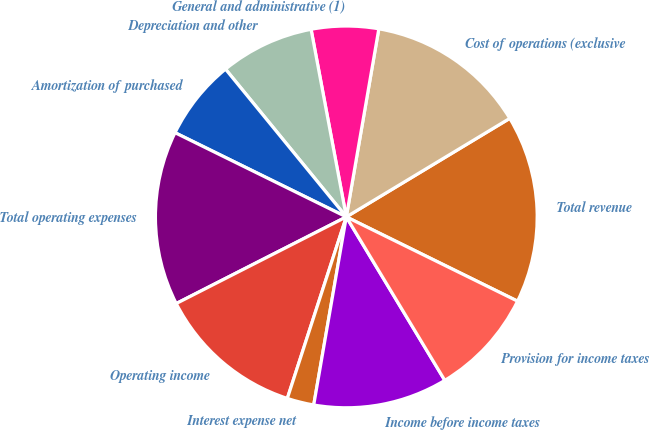Convert chart. <chart><loc_0><loc_0><loc_500><loc_500><pie_chart><fcel>Total revenue<fcel>Cost of operations (exclusive<fcel>General and administrative (1)<fcel>Depreciation and other<fcel>Amortization of purchased<fcel>Total operating expenses<fcel>Operating income<fcel>Interest expense net<fcel>Income before income taxes<fcel>Provision for income taxes<nl><fcel>15.91%<fcel>13.64%<fcel>5.68%<fcel>7.95%<fcel>6.82%<fcel>14.77%<fcel>12.5%<fcel>2.27%<fcel>11.36%<fcel>9.09%<nl></chart> 